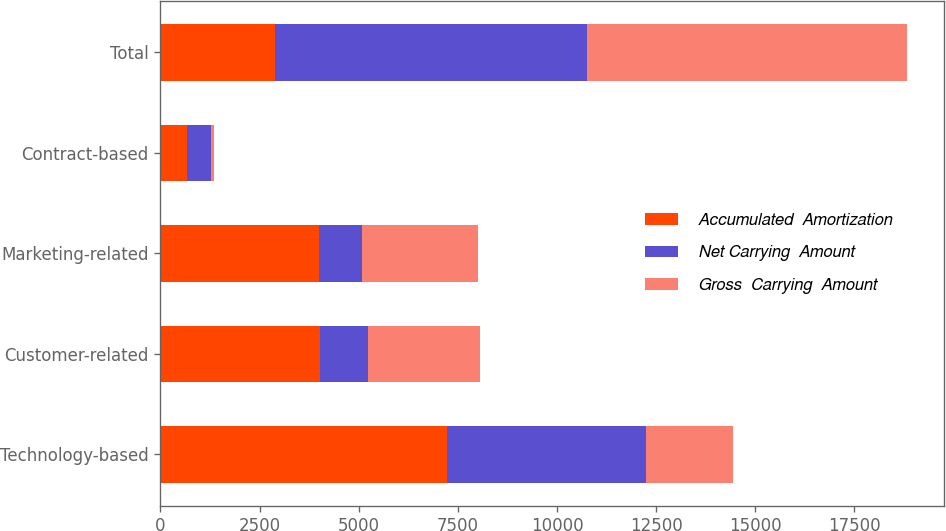Convert chart to OTSL. <chart><loc_0><loc_0><loc_500><loc_500><stacked_bar_chart><ecel><fcel>Technology-based<fcel>Customer-related<fcel>Marketing-related<fcel>Contract-based<fcel>Total<nl><fcel>Accumulated  Amortization<fcel>7220<fcel>4031<fcel>4006<fcel>679<fcel>2880.5<nl><fcel>Net Carrying  Amount<fcel>5018<fcel>1205<fcel>1071<fcel>589<fcel>7883<nl><fcel>Gross  Carrying  Amount<fcel>2202<fcel>2826<fcel>2935<fcel>90<fcel>8053<nl></chart> 